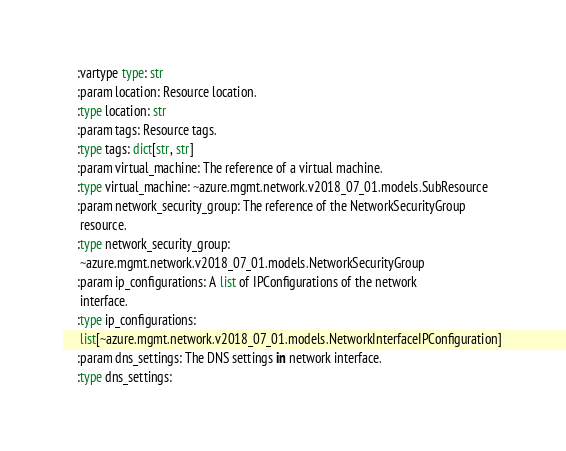<code> <loc_0><loc_0><loc_500><loc_500><_Python_>    :vartype type: str
    :param location: Resource location.
    :type location: str
    :param tags: Resource tags.
    :type tags: dict[str, str]
    :param virtual_machine: The reference of a virtual machine.
    :type virtual_machine: ~azure.mgmt.network.v2018_07_01.models.SubResource
    :param network_security_group: The reference of the NetworkSecurityGroup
     resource.
    :type network_security_group:
     ~azure.mgmt.network.v2018_07_01.models.NetworkSecurityGroup
    :param ip_configurations: A list of IPConfigurations of the network
     interface.
    :type ip_configurations:
     list[~azure.mgmt.network.v2018_07_01.models.NetworkInterfaceIPConfiguration]
    :param dns_settings: The DNS settings in network interface.
    :type dns_settings:</code> 